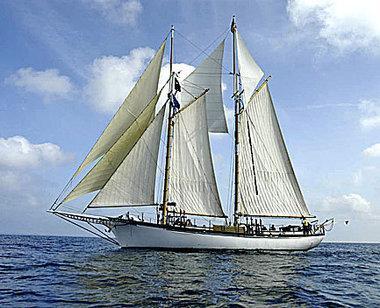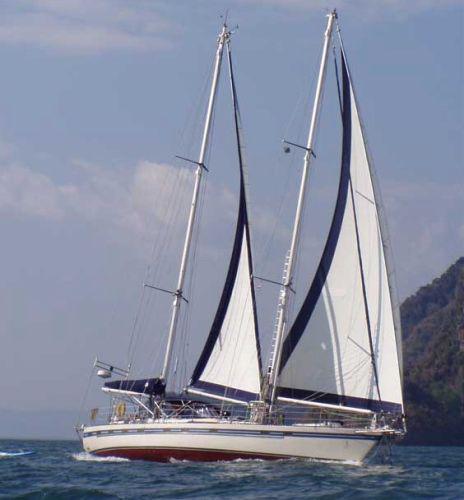The first image is the image on the left, the second image is the image on the right. For the images shown, is this caption "The sailboat in the right image is tipped rightward, showing its interior." true? Answer yes or no. No. The first image is the image on the left, the second image is the image on the right. Examine the images to the left and right. Is the description "One boat only has two sails unfurled." accurate? Answer yes or no. Yes. 